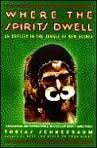What is the title of this book? The title of the book is 'Where the Spirits Dwell: An Odyssey in the New Guinea Jungle,' suggesting an intriguing exploration into the depths of New Guinea. 